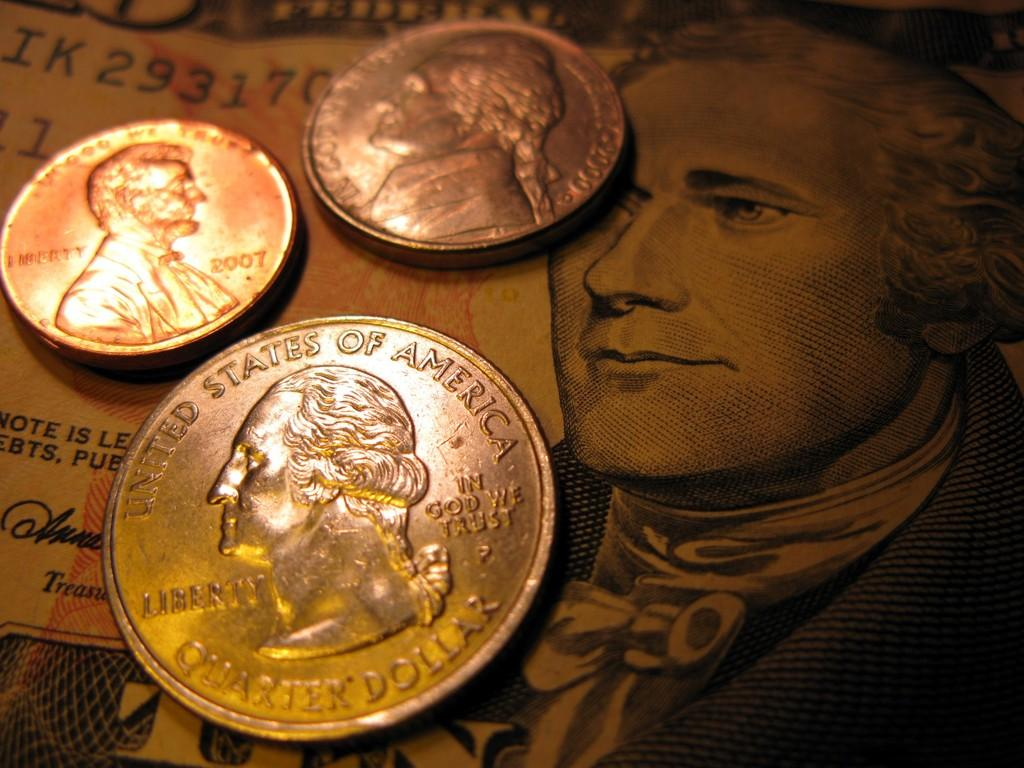<image>
Relay a brief, clear account of the picture shown. United States of America quarter dollar silver coin. 